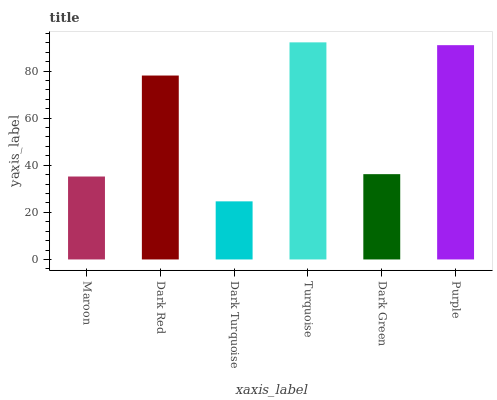Is Dark Turquoise the minimum?
Answer yes or no. Yes. Is Turquoise the maximum?
Answer yes or no. Yes. Is Dark Red the minimum?
Answer yes or no. No. Is Dark Red the maximum?
Answer yes or no. No. Is Dark Red greater than Maroon?
Answer yes or no. Yes. Is Maroon less than Dark Red?
Answer yes or no. Yes. Is Maroon greater than Dark Red?
Answer yes or no. No. Is Dark Red less than Maroon?
Answer yes or no. No. Is Dark Red the high median?
Answer yes or no. Yes. Is Dark Green the low median?
Answer yes or no. Yes. Is Dark Turquoise the high median?
Answer yes or no. No. Is Dark Turquoise the low median?
Answer yes or no. No. 